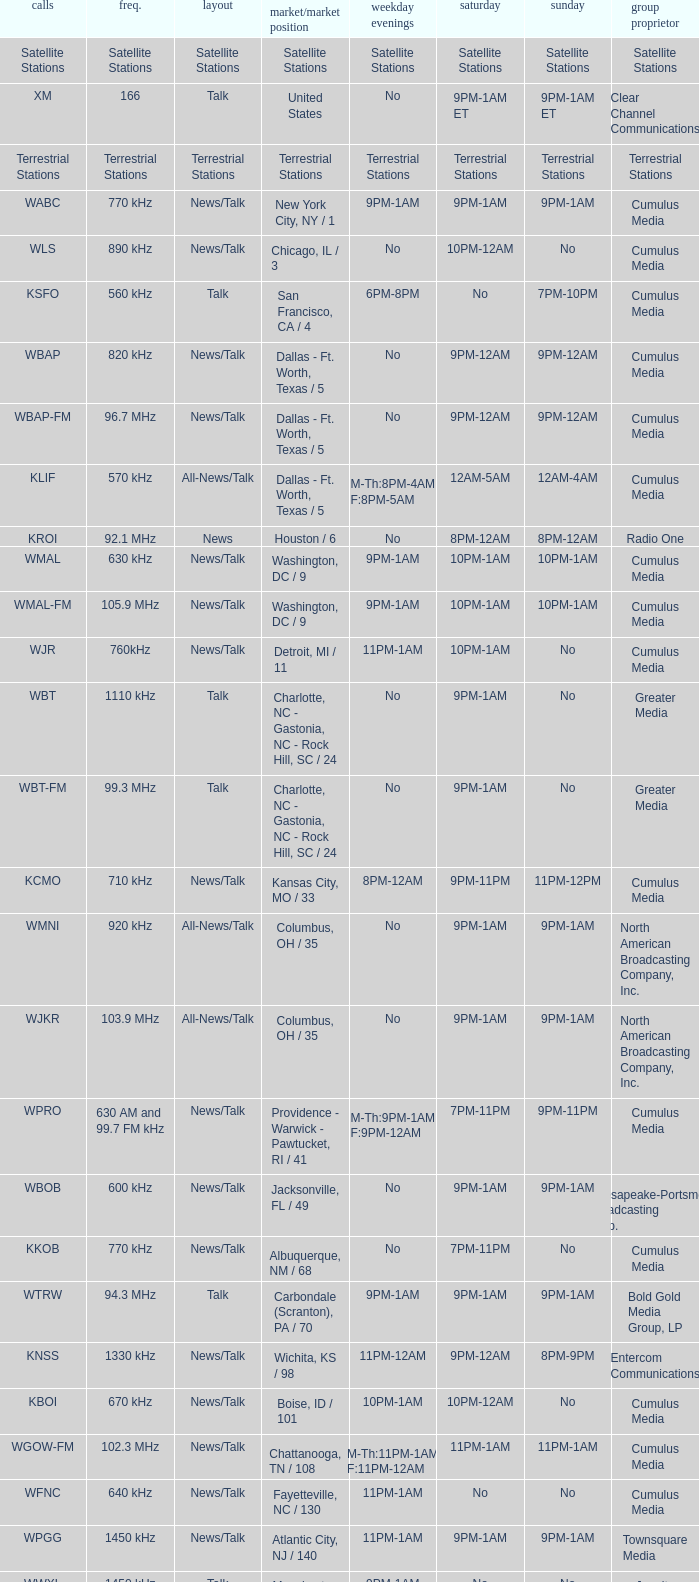What is the market for the 11pm-1am Saturday game? Chattanooga, TN / 108. 